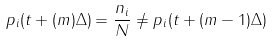<formula> <loc_0><loc_0><loc_500><loc_500>p _ { i } ( t + ( m ) \Delta ) = \frac { n _ { i } } { N } \neq p _ { i } ( t + ( m - 1 ) \Delta )</formula> 